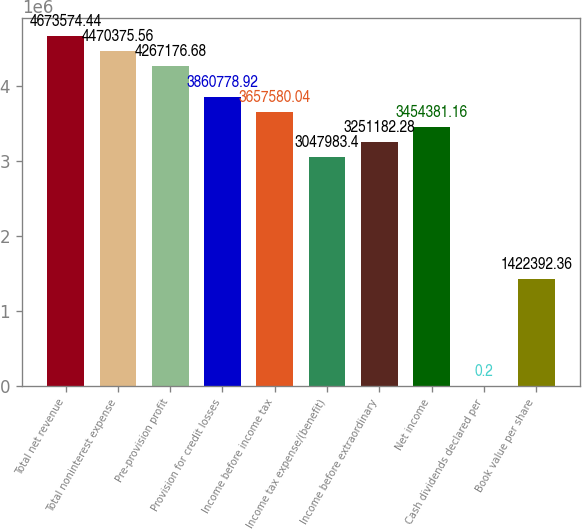<chart> <loc_0><loc_0><loc_500><loc_500><bar_chart><fcel>Total net revenue<fcel>Total noninterest expense<fcel>Pre-provision profit<fcel>Provision for credit losses<fcel>Income before income tax<fcel>Income tax expense/(benefit)<fcel>Income before extraordinary<fcel>Net income<fcel>Cash dividends declared per<fcel>Book value per share<nl><fcel>4.67357e+06<fcel>4.47038e+06<fcel>4.26718e+06<fcel>3.86078e+06<fcel>3.65758e+06<fcel>3.04798e+06<fcel>3.25118e+06<fcel>3.45438e+06<fcel>0.2<fcel>1.42239e+06<nl></chart> 